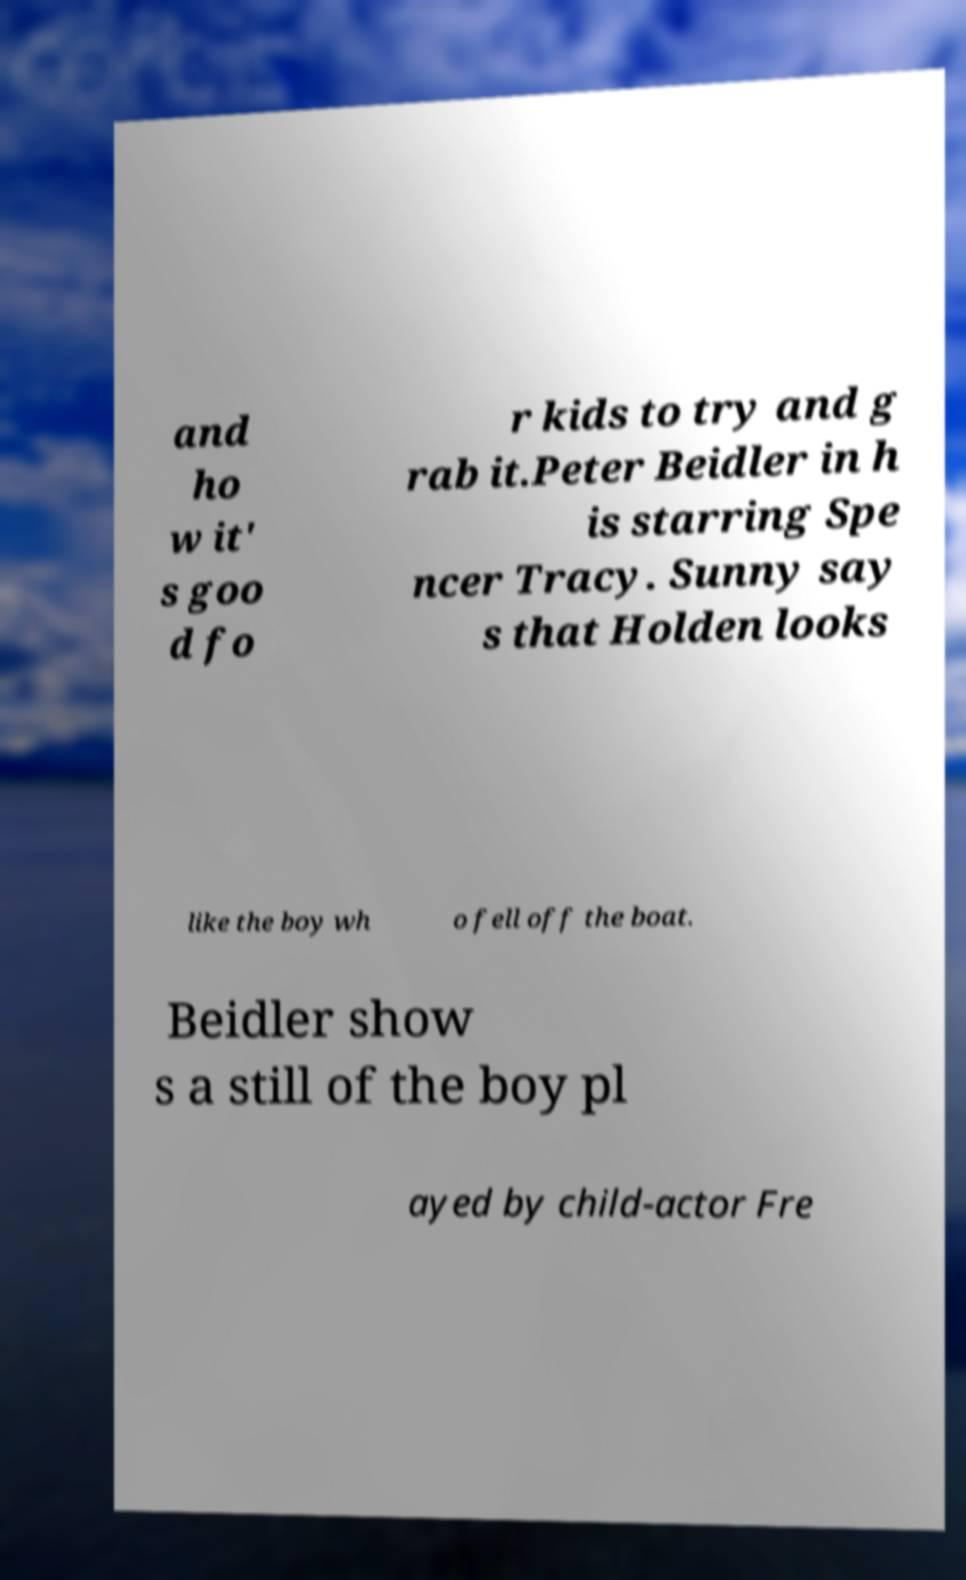Could you assist in decoding the text presented in this image and type it out clearly? and ho w it' s goo d fo r kids to try and g rab it.Peter Beidler in h is starring Spe ncer Tracy. Sunny say s that Holden looks like the boy wh o fell off the boat. Beidler show s a still of the boy pl ayed by child-actor Fre 